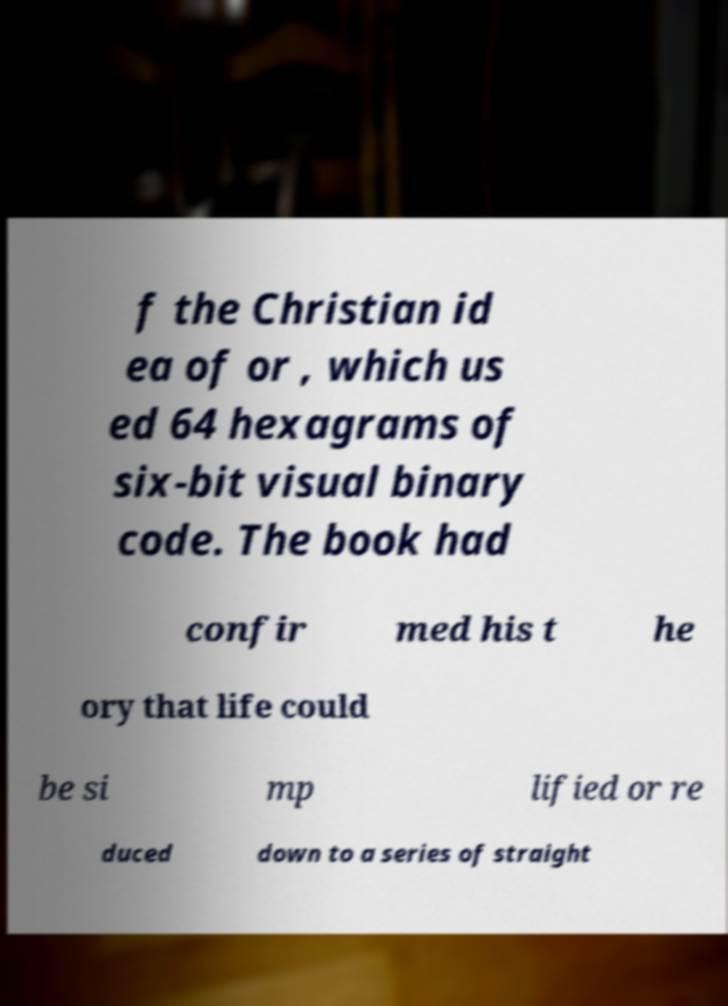Please read and relay the text visible in this image. What does it say? f the Christian id ea of or , which us ed 64 hexagrams of six-bit visual binary code. The book had confir med his t he ory that life could be si mp lified or re duced down to a series of straight 